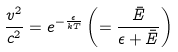<formula> <loc_0><loc_0><loc_500><loc_500>\frac { v ^ { 2 } } { c ^ { 2 } } = e ^ { - \frac { \epsilon } { k T } } \left ( = \frac { \bar { E } } { \epsilon + \bar { E } } \right )</formula> 